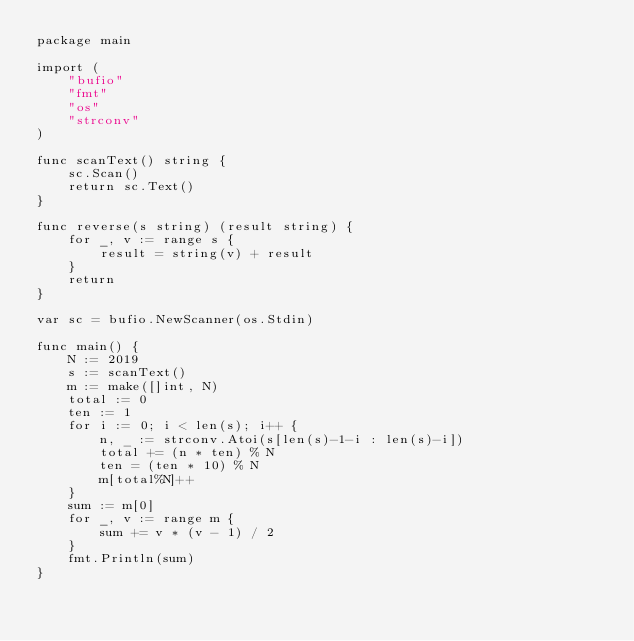Convert code to text. <code><loc_0><loc_0><loc_500><loc_500><_Go_>package main

import (
	"bufio"
	"fmt"
	"os"
	"strconv"
)

func scanText() string {
	sc.Scan()
	return sc.Text()
}

func reverse(s string) (result string) {
	for _, v := range s {
		result = string(v) + result
	}
	return
}

var sc = bufio.NewScanner(os.Stdin)

func main() {
	N := 2019
	s := scanText()
	m := make([]int, N)
	total := 0
	ten := 1
	for i := 0; i < len(s); i++ {
		n, _ := strconv.Atoi(s[len(s)-1-i : len(s)-i])
		total += (n * ten) % N
		ten = (ten * 10) % N
		m[total%N]++
	}
	sum := m[0]
	for _, v := range m {
		sum += v * (v - 1) / 2
	}
	fmt.Println(sum)
}
</code> 